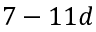Convert formula to latex. <formula><loc_0><loc_0><loc_500><loc_500>7 - 1 1 d</formula> 